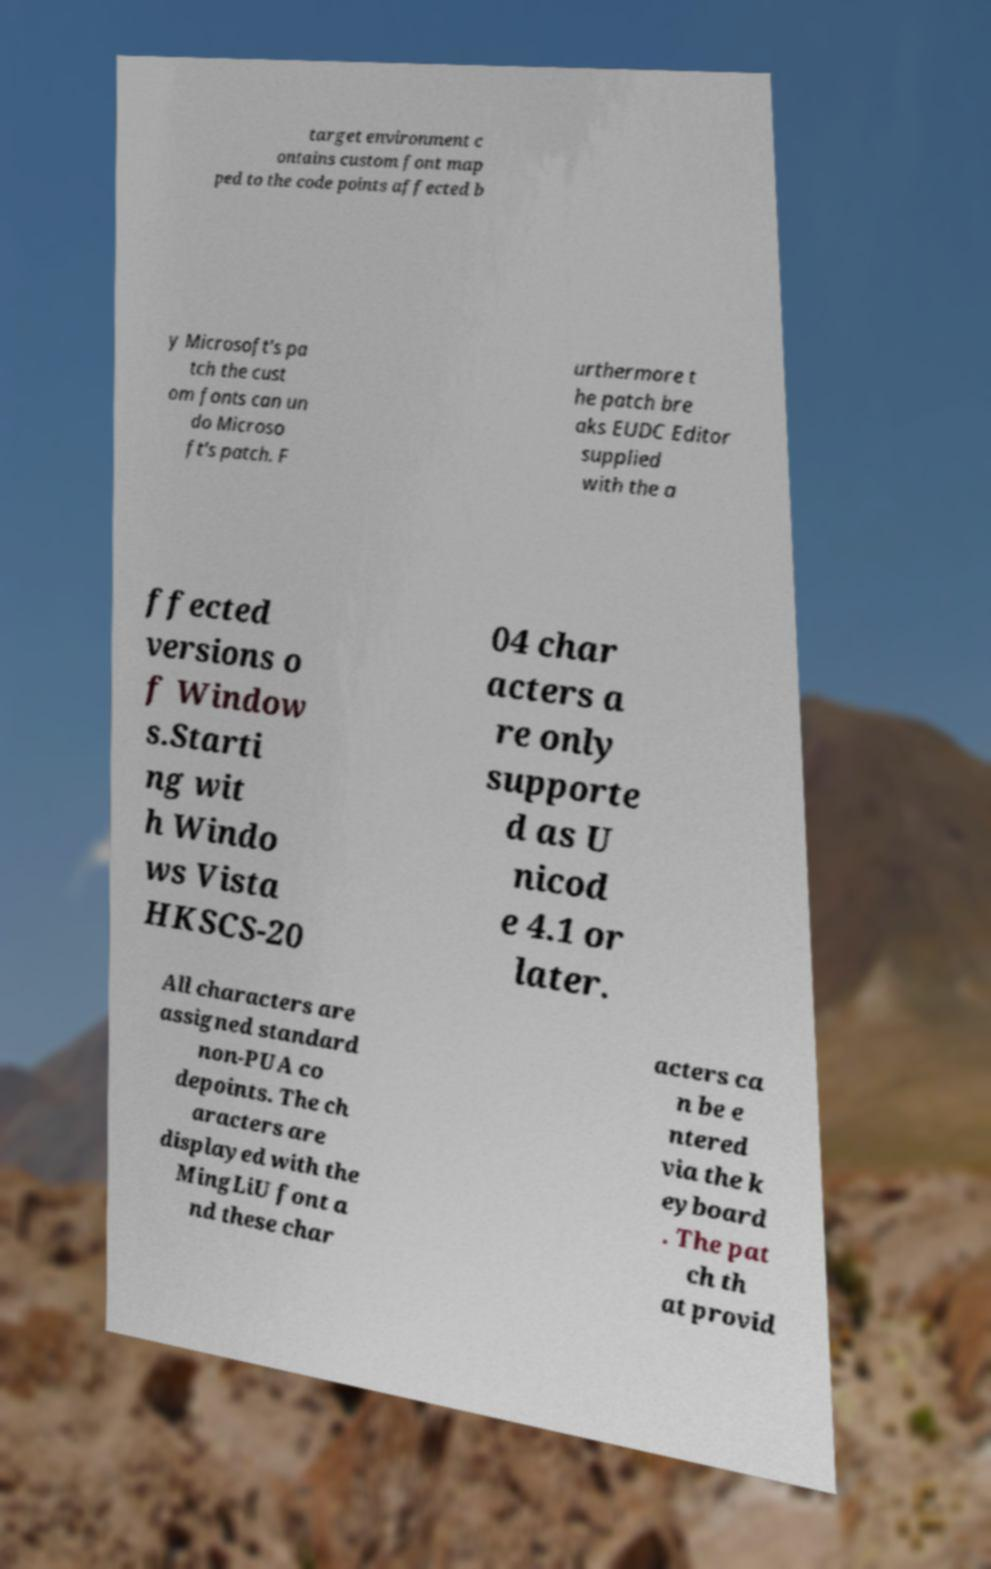Could you extract and type out the text from this image? target environment c ontains custom font map ped to the code points affected b y Microsoft's pa tch the cust om fonts can un do Microso ft's patch. F urthermore t he patch bre aks EUDC Editor supplied with the a ffected versions o f Window s.Starti ng wit h Windo ws Vista HKSCS-20 04 char acters a re only supporte d as U nicod e 4.1 or later. All characters are assigned standard non-PUA co depoints. The ch aracters are displayed with the MingLiU font a nd these char acters ca n be e ntered via the k eyboard . The pat ch th at provid 